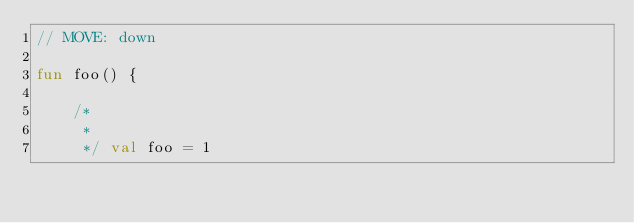Convert code to text. <code><loc_0><loc_0><loc_500><loc_500><_Kotlin_>// MOVE: down

fun foo() {

    /*
     *
     */ val foo = 1</code> 